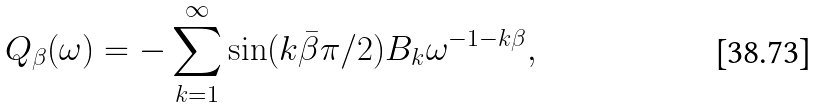Convert formula to latex. <formula><loc_0><loc_0><loc_500><loc_500>Q _ { \beta } ( \omega ) = - \sum _ { k = 1 } ^ { \infty } \sin ( k \bar { \beta } \pi / 2 ) B _ { k } { \omega } ^ { - 1 - k \beta } ,</formula> 